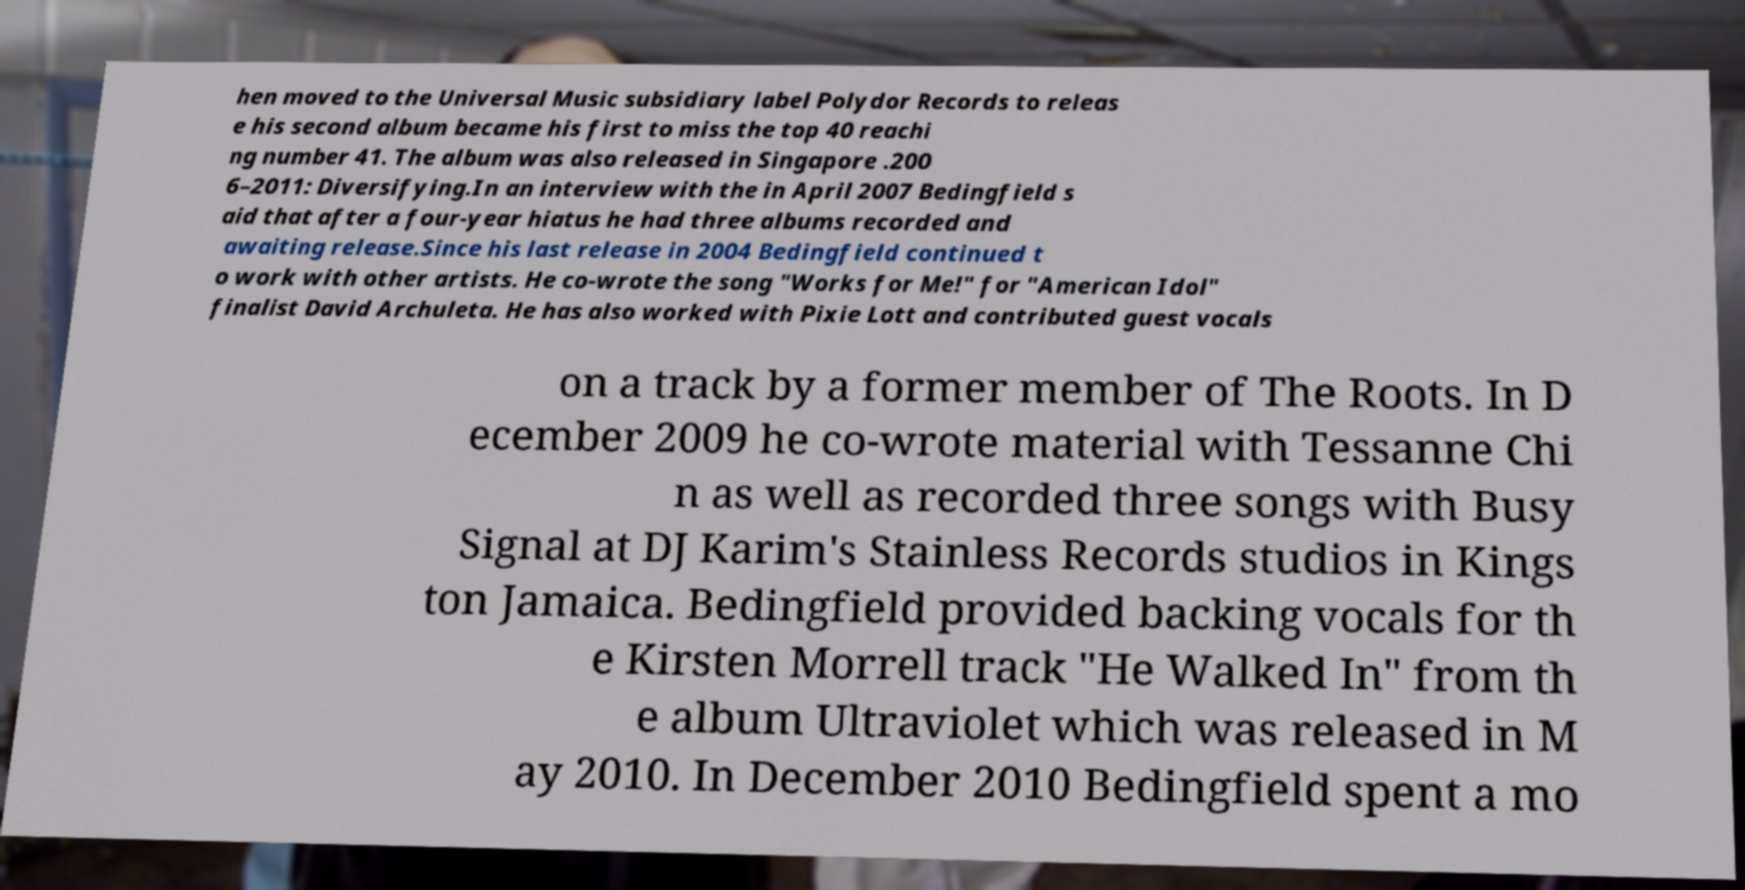Could you assist in decoding the text presented in this image and type it out clearly? hen moved to the Universal Music subsidiary label Polydor Records to releas e his second album became his first to miss the top 40 reachi ng number 41. The album was also released in Singapore .200 6–2011: Diversifying.In an interview with the in April 2007 Bedingfield s aid that after a four-year hiatus he had three albums recorded and awaiting release.Since his last release in 2004 Bedingfield continued t o work with other artists. He co-wrote the song "Works for Me!" for "American Idol" finalist David Archuleta. He has also worked with Pixie Lott and contributed guest vocals on a track by a former member of The Roots. In D ecember 2009 he co-wrote material with Tessanne Chi n as well as recorded three songs with Busy Signal at DJ Karim's Stainless Records studios in Kings ton Jamaica. Bedingfield provided backing vocals for th e Kirsten Morrell track "He Walked In" from th e album Ultraviolet which was released in M ay 2010. In December 2010 Bedingfield spent a mo 